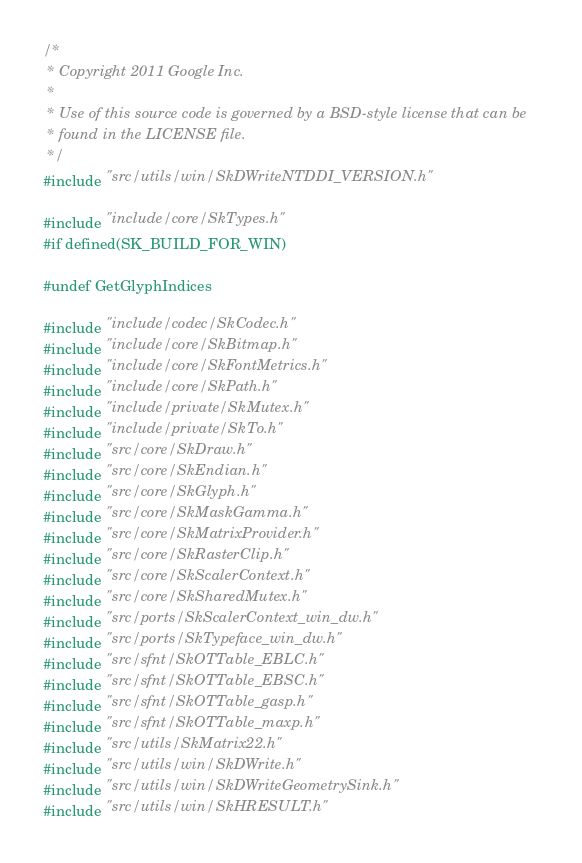<code> <loc_0><loc_0><loc_500><loc_500><_C++_>/*
 * Copyright 2011 Google Inc.
 *
 * Use of this source code is governed by a BSD-style license that can be
 * found in the LICENSE file.
 */
#include "src/utils/win/SkDWriteNTDDI_VERSION.h"

#include "include/core/SkTypes.h"
#if defined(SK_BUILD_FOR_WIN)

#undef GetGlyphIndices

#include "include/codec/SkCodec.h"
#include "include/core/SkBitmap.h"
#include "include/core/SkFontMetrics.h"
#include "include/core/SkPath.h"
#include "include/private/SkMutex.h"
#include "include/private/SkTo.h"
#include "src/core/SkDraw.h"
#include "src/core/SkEndian.h"
#include "src/core/SkGlyph.h"
#include "src/core/SkMaskGamma.h"
#include "src/core/SkMatrixProvider.h"
#include "src/core/SkRasterClip.h"
#include "src/core/SkScalerContext.h"
#include "src/core/SkSharedMutex.h"
#include "src/ports/SkScalerContext_win_dw.h"
#include "src/ports/SkTypeface_win_dw.h"
#include "src/sfnt/SkOTTable_EBLC.h"
#include "src/sfnt/SkOTTable_EBSC.h"
#include "src/sfnt/SkOTTable_gasp.h"
#include "src/sfnt/SkOTTable_maxp.h"
#include "src/utils/SkMatrix22.h"
#include "src/utils/win/SkDWrite.h"
#include "src/utils/win/SkDWriteGeometrySink.h"
#include "src/utils/win/SkHRESULT.h"</code> 